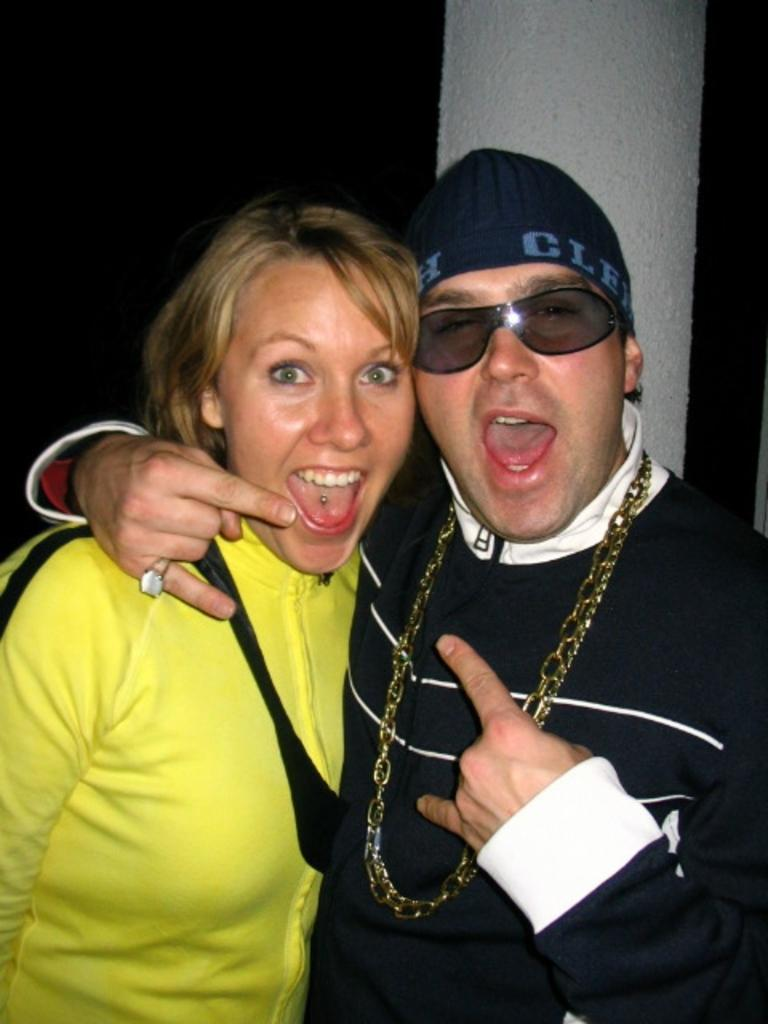How many people are present in the image? There are two people standing in the image. Can you describe the woman on the left side of the image? The woman on the left side of the image is wearing a yellow dress. Are there any specific accessories or features that can be seen on any of the people in the image? Yes, there is a person wearing glasses in the image. What type of meat is being cooked in the background of the image? There is no meat or cooking activity visible in the image. 